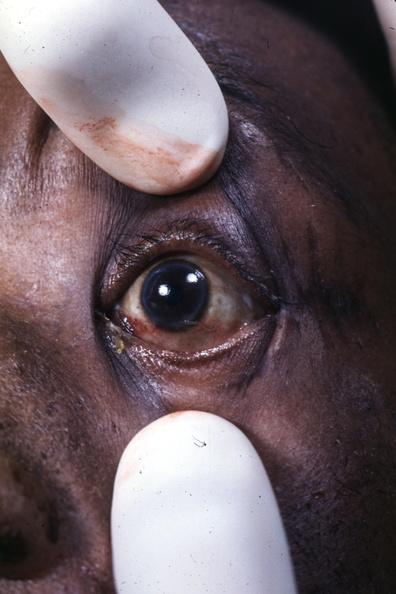s this x-ray of sella turcica after removal postmort present?
Answer the question using a single word or phrase. No 